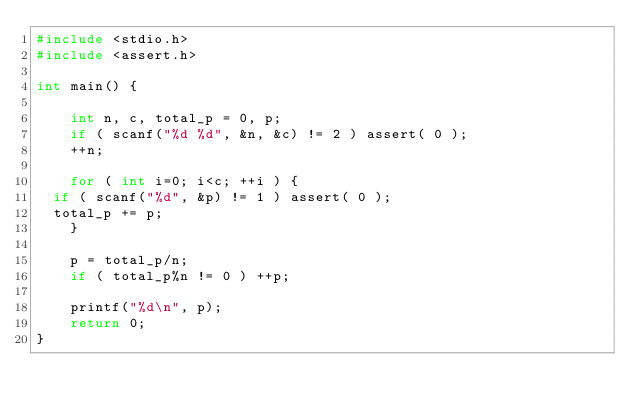Convert code to text. <code><loc_0><loc_0><loc_500><loc_500><_C_>#include <stdio.h>
#include <assert.h>

int main() {

    int n, c, total_p = 0, p;
    if ( scanf("%d %d", &n, &c) != 2 ) assert( 0 );
    ++n;
    
    for ( int i=0; i<c; ++i ) {
	if ( scanf("%d", &p) != 1 ) assert( 0 );
	total_p += p;
    }

    p = total_p/n;
    if ( total_p%n != 0 ) ++p;

    printf("%d\n", p);
    return 0;
}

</code> 